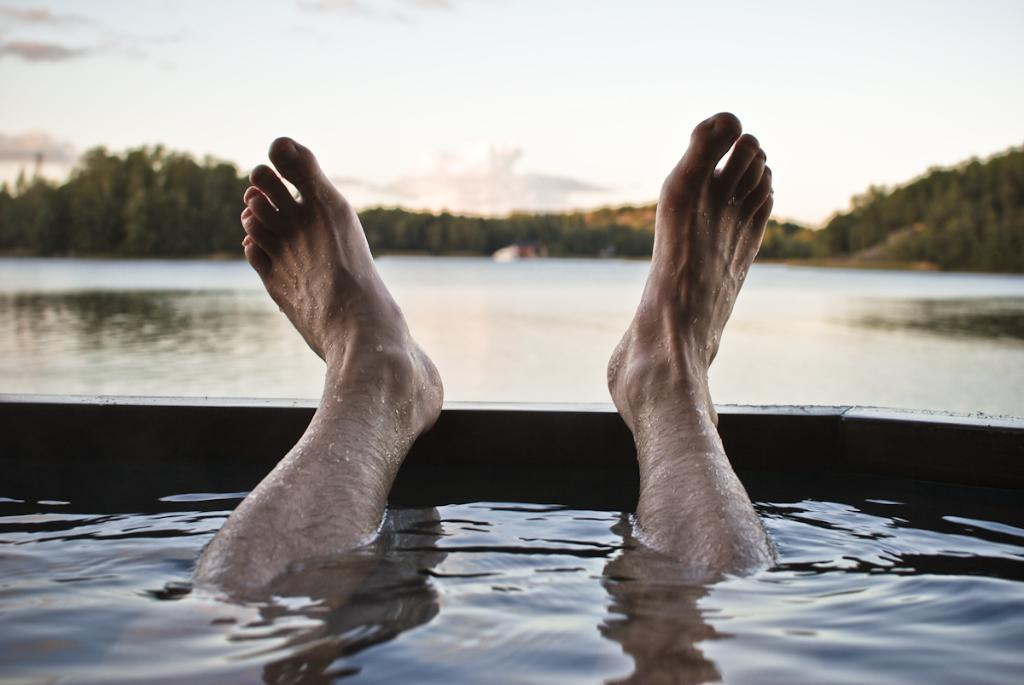What part of a person can be seen in the water in the image? There are a person's legs in the water in the image. What type of water is the person's legs in? The water appears to be a sea. What can be seen in the background of the image? There are trees in the background of the image. What is visible at the top of the image? The sky is visible at the top of the image. How many boys are playing in the wilderness in the image? There are no boys or wilderness present in the image; it features a person's legs in the sea with trees in the background and the sky visible at the top. What type of furniture can be seen in the bedroom in the image? There is no bedroom present in the image. 